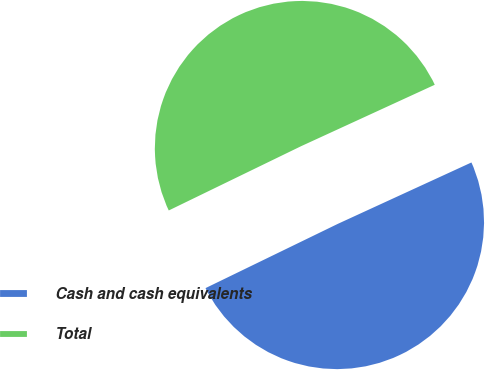Convert chart to OTSL. <chart><loc_0><loc_0><loc_500><loc_500><pie_chart><fcel>Cash and cash equivalents<fcel>Total<nl><fcel>49.66%<fcel>50.34%<nl></chart> 